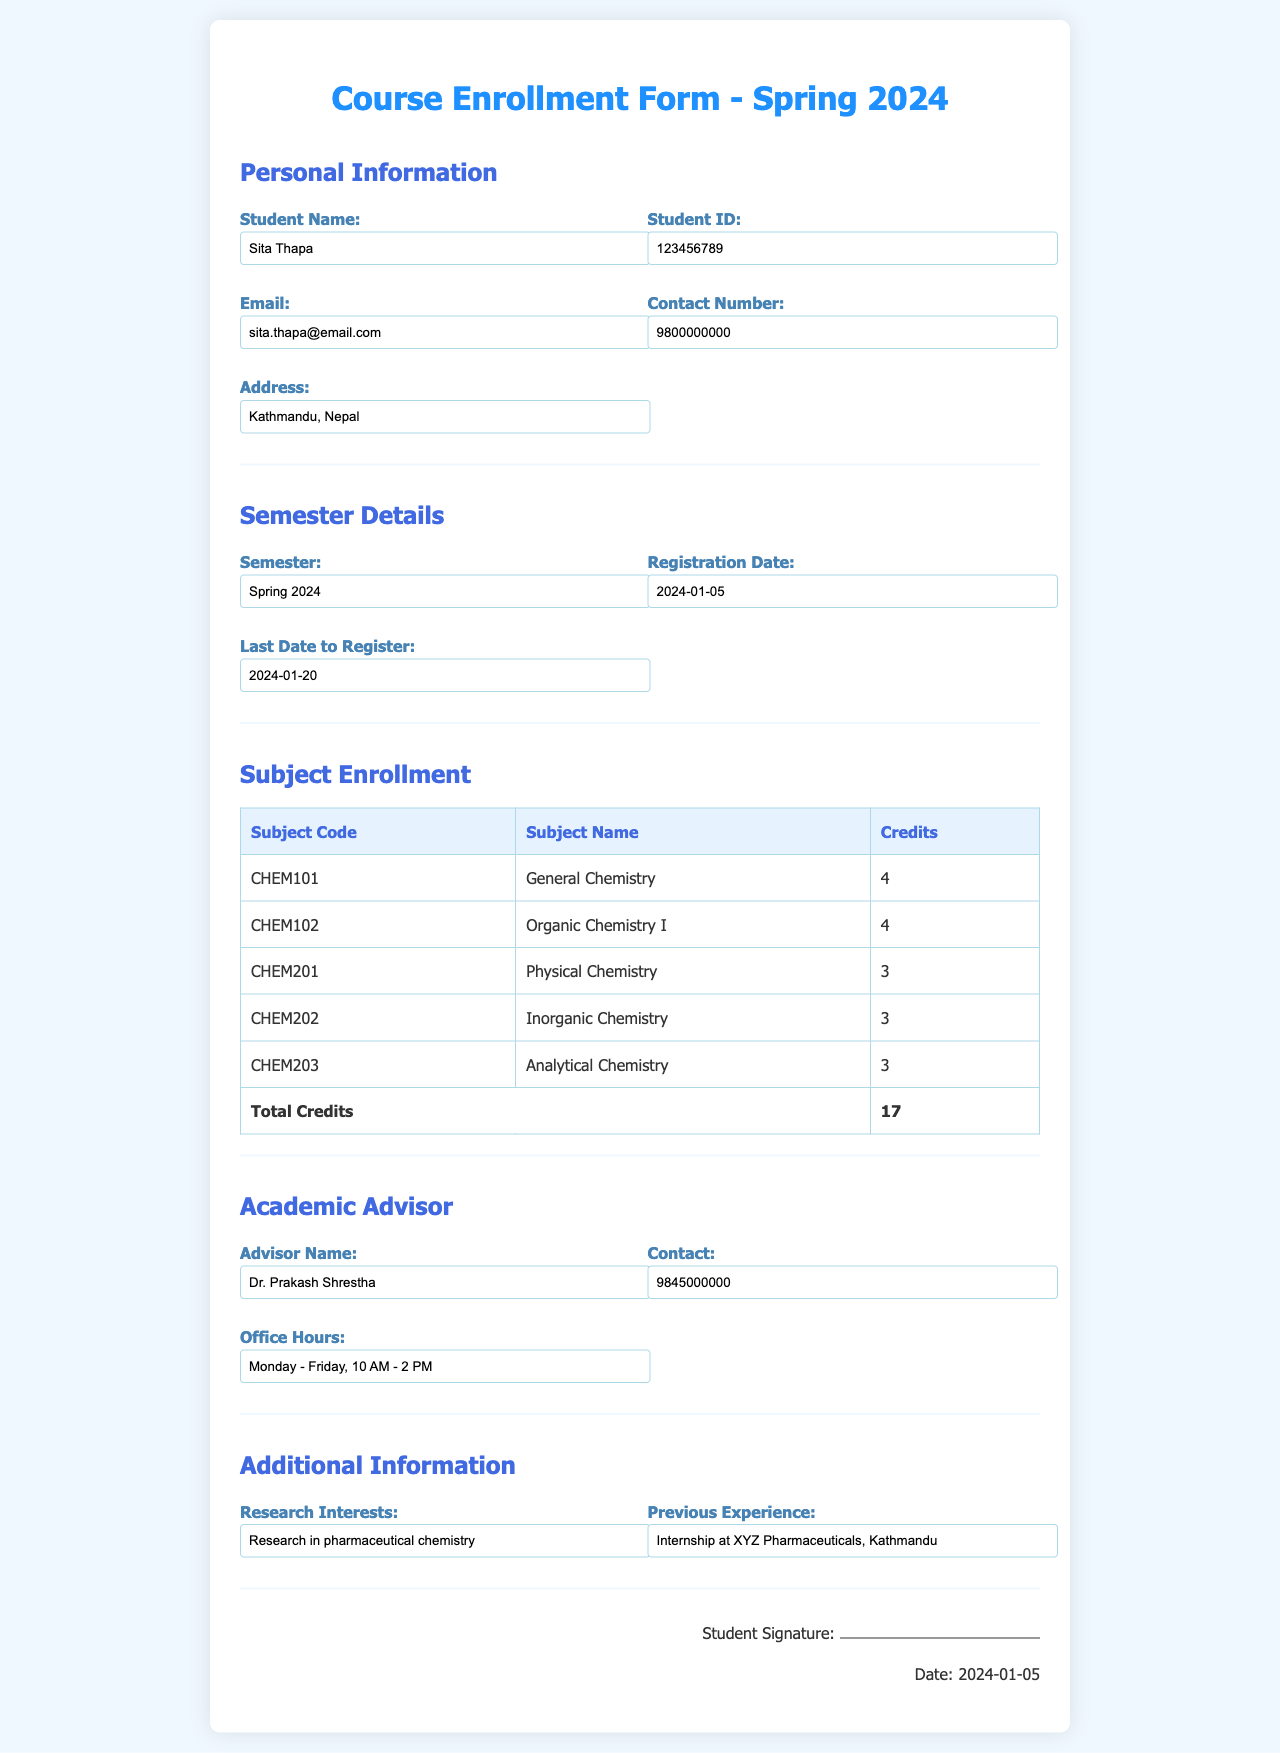What is the student name? The student's name is listed under Personal Information in the document.
Answer: Sita Thapa What is the student ID? The student ID can be found in the Personal Information section of the form.
Answer: 123456789 What is the registration date? The registration date is specified in the Semester Details section.
Answer: 2024-01-05 How many total credits are there? The total credits are calculated based on the subjects listed in the Subject Enrollment section.
Answer: 17 What is the name of the academic advisor? The advisor's name is provided in the Academic Advisor section of the document.
Answer: Dr. Prakash Shrestha What are the office hours of the academic advisor? The office hours are mentioned under the Academic Advisor section in the document.
Answer: Monday - Friday, 10 AM - 2 PM Which subject has the code CHEM201? By looking at the Subject Enrollment section, we can identify the subject associated with that code.
Answer: Physical Chemistry What is the contact number of the advisor? The contact number is provided in the Academic Advisor section.
Answer: 9845000000 What is one of the research interests mentioned? The research interests are listed in the Additional Information section of the form.
Answer: Research in pharmaceutical chemistry 